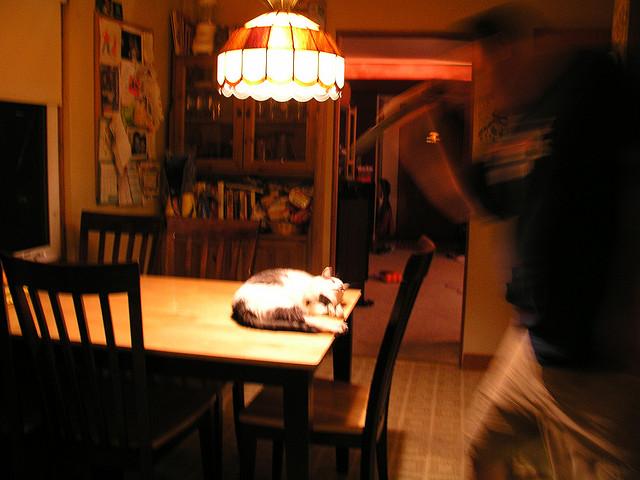What is on the table?
Answer briefly. Cat. Is there a person in the picture?
Write a very short answer. Yes. What is the table made of?
Short answer required. Wood. 